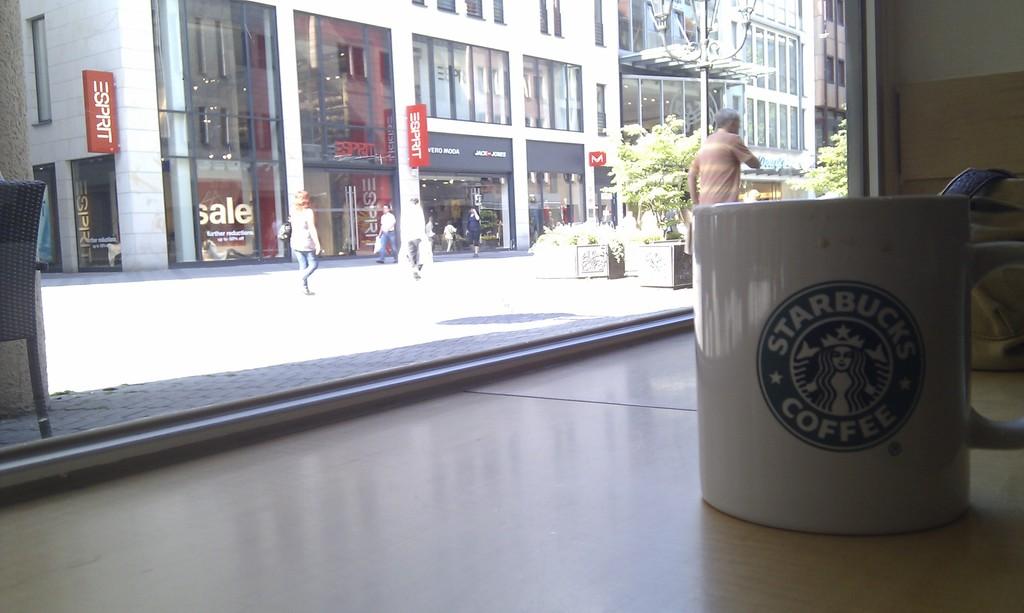What brand of mug?
Your response must be concise. Starbucks. What brand is the drink?
Offer a very short reply. Starbucks. 